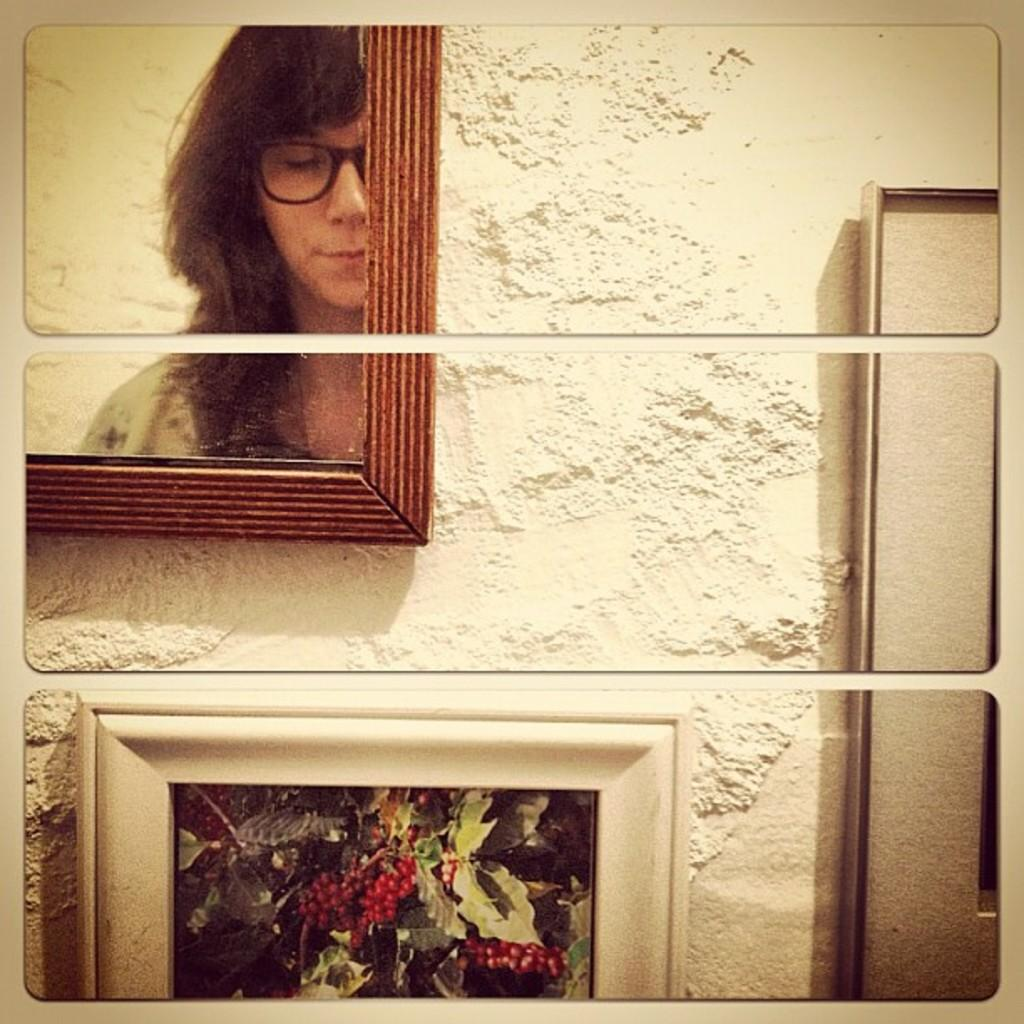How is the frame in the image divided? The frame in the image is split into three pieces. What can be seen in one of the sections of the frame? There is a person's reflection in a mirror in the image. What is the color of the surface that the frames are attached to? The frames are attached to a cream-colored surface in the image. How many roses are present in the image? There are no roses visible in the image. What type of school can be seen in the image? There is no school present in the image. 